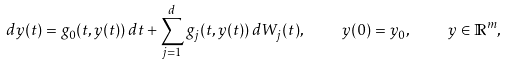<formula> <loc_0><loc_0><loc_500><loc_500>d y ( t ) = g _ { 0 } ( t , y ( t ) ) \, d t + \sum _ { j = 1 } ^ { d } g _ { j } ( t , y ( t ) ) \, d W _ { j } ( t ) , \quad y ( 0 ) = y _ { 0 } , \quad y \in \mathbb { R } ^ { m } ,</formula> 